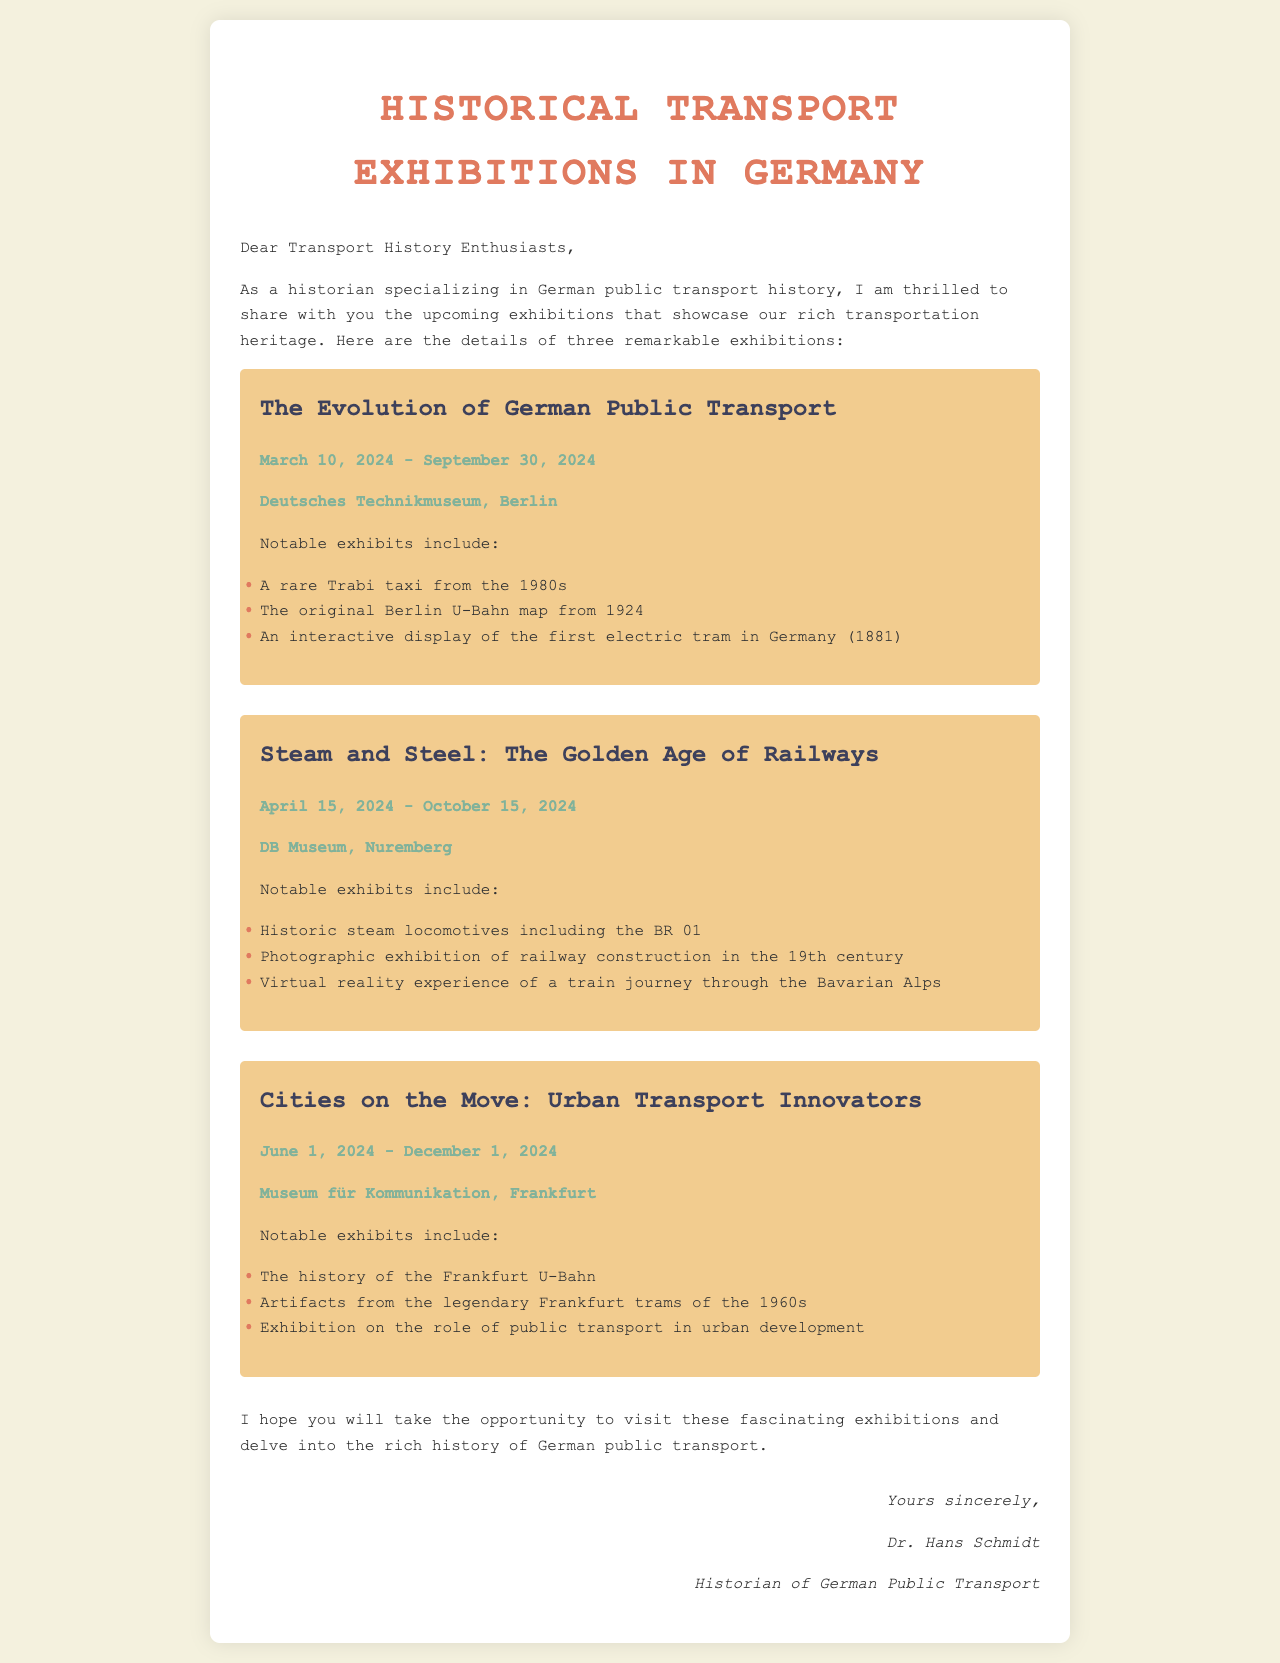What is the title of the first exhibition? The title of the first exhibition is given right above the date and location in the section.
Answer: The Evolution of German Public Transport What are the dates for the second exhibition? The dates for the second exhibition are specified under the exhibition's title.
Answer: April 15, 2024 - October 15, 2024 Where is the exhibition on urban transport located? The location of the exhibition is mentioned before the notable exhibits list for that exhibition.
Answer: Museum für Kommunikation, Frankfurt What notable exhibit is featured at the first exhibition? The notable exhibits are listed under each exhibition, and the first item is representative of that exhibition.
Answer: A rare Trabi taxi from the 1980s Which museum hosts the steam and steel exhibition? The hosting museum is directly stated after the exhibition title and before the dates.
Answer: DB Museum, Nuremberg How long does the cities on the move exhibition run? The duration is indicated by the dates provided for that particular exhibition.
Answer: June 1, 2024 - December 1, 2024 Who is the signature of the letter from? The signature is found at the bottom of the document, identifying the author.
Answer: Dr. Hans Schmidt What is the theme of the second exhibition? The theme is represented in the title of the exhibition and gives insight into its focus.
Answer: Steam and Steel: The Golden Age of Railways What aspect of public transport is highlighted in the third exhibition? The exhibition's content is summarized in its notable exhibits, reflecting its focus.
Answer: The role of public transport in urban development 